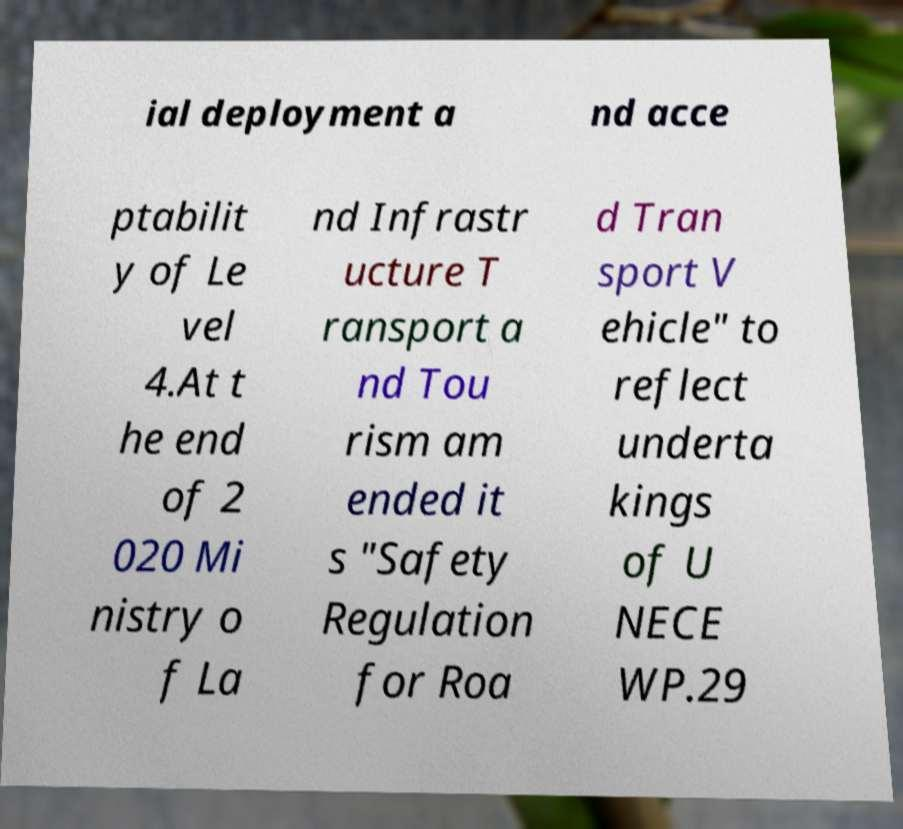What messages or text are displayed in this image? I need them in a readable, typed format. ial deployment a nd acce ptabilit y of Le vel 4.At t he end of 2 020 Mi nistry o f La nd Infrastr ucture T ransport a nd Tou rism am ended it s "Safety Regulation for Roa d Tran sport V ehicle" to reflect underta kings of U NECE WP.29 